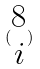<formula> <loc_0><loc_0><loc_500><loc_500>( \begin{matrix} 8 \\ i \end{matrix} )</formula> 